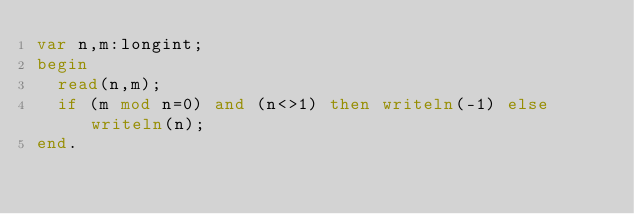<code> <loc_0><loc_0><loc_500><loc_500><_Pascal_>var n,m:longint;
begin
  read(n,m);
  if (m mod n=0) and (n<>1) then writeln(-1) else writeln(n);
end.</code> 